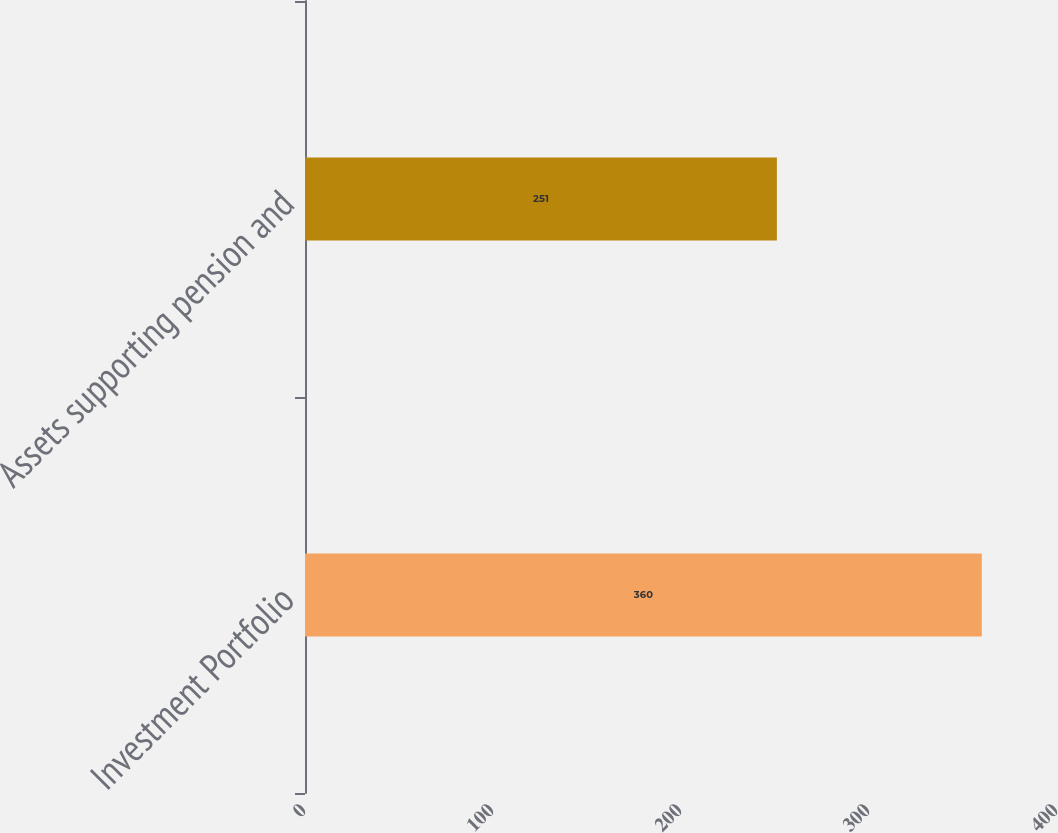Convert chart to OTSL. <chart><loc_0><loc_0><loc_500><loc_500><bar_chart><fcel>Investment Portfolio<fcel>Assets supporting pension and<nl><fcel>360<fcel>251<nl></chart> 